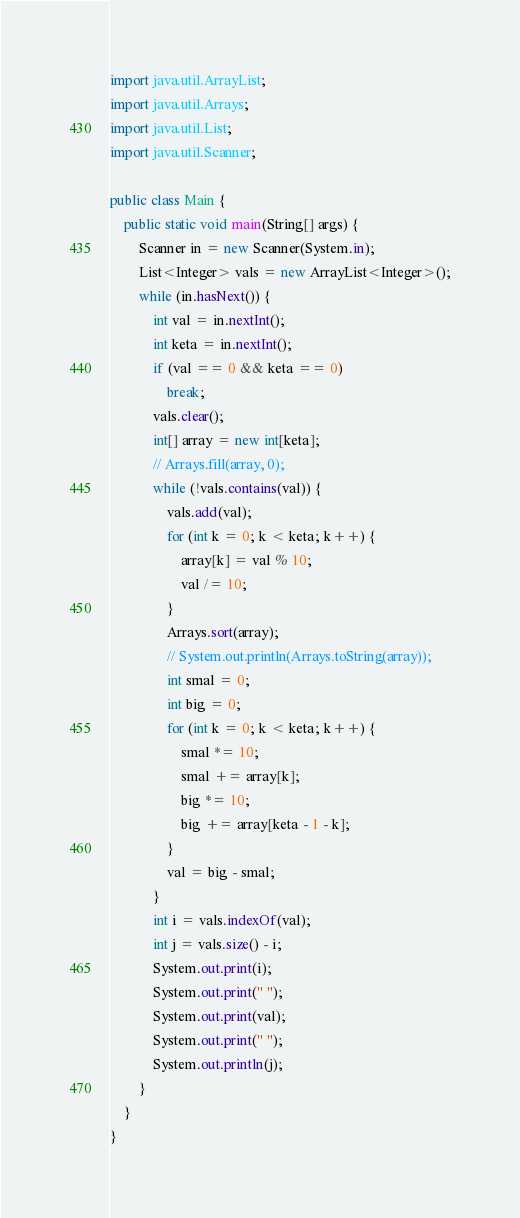Convert code to text. <code><loc_0><loc_0><loc_500><loc_500><_Java_>import java.util.ArrayList;
import java.util.Arrays;
import java.util.List;
import java.util.Scanner;

public class Main {
	public static void main(String[] args) {
		Scanner in = new Scanner(System.in);
		List<Integer> vals = new ArrayList<Integer>();
		while (in.hasNext()) {
			int val = in.nextInt();
			int keta = in.nextInt();
			if (val == 0 && keta == 0)
				break;
			vals.clear();
			int[] array = new int[keta];
			// Arrays.fill(array, 0);
			while (!vals.contains(val)) {
				vals.add(val);
				for (int k = 0; k < keta; k++) {
					array[k] = val % 10;
					val /= 10;
				}
				Arrays.sort(array);
				// System.out.println(Arrays.toString(array));
				int smal = 0;
				int big = 0;
				for (int k = 0; k < keta; k++) {
					smal *= 10;
					smal += array[k];
					big *= 10;
					big += array[keta - 1 - k];
				}
				val = big - smal;
			}
			int i = vals.indexOf(val);
			int j = vals.size() - i;
			System.out.print(i);
			System.out.print(" ");
			System.out.print(val);
			System.out.print(" ");
			System.out.println(j);
		}
	}
}</code> 